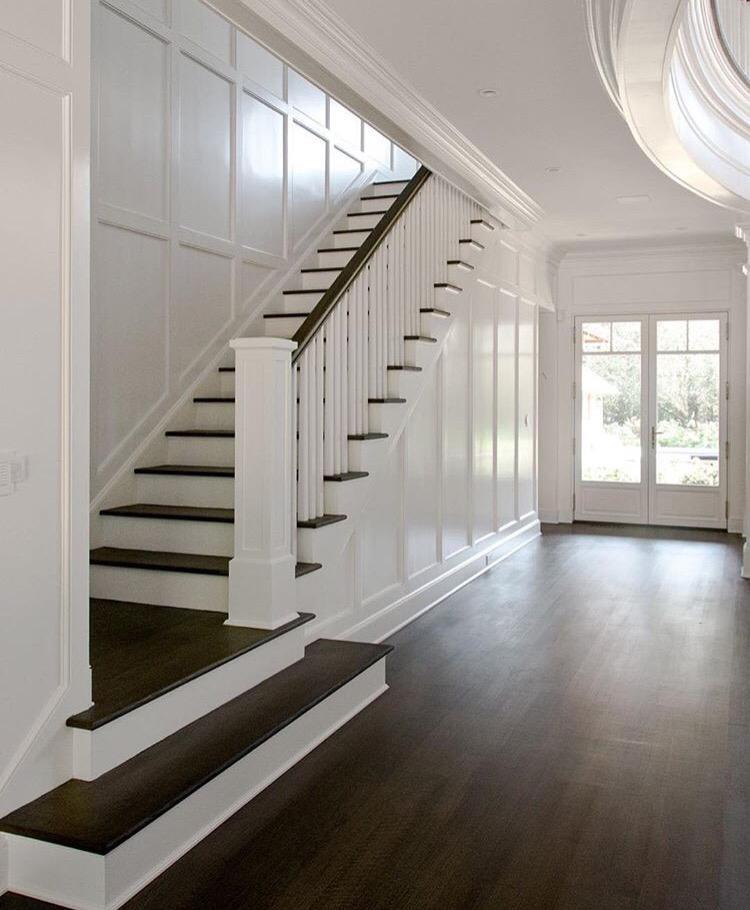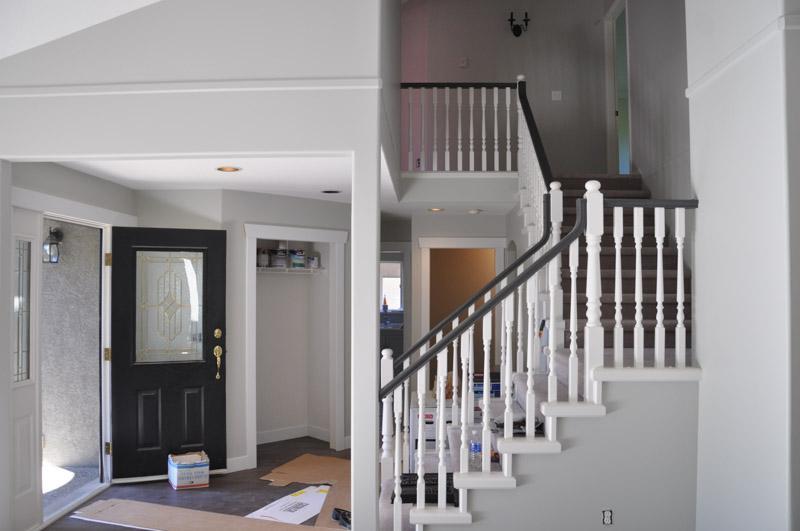The first image is the image on the left, the second image is the image on the right. For the images shown, is this caption "One image shows a cream-carpeted staircase that starts at the lower right, ascends, and turns back to the right, with a light fixture suspended over it." true? Answer yes or no. No. 